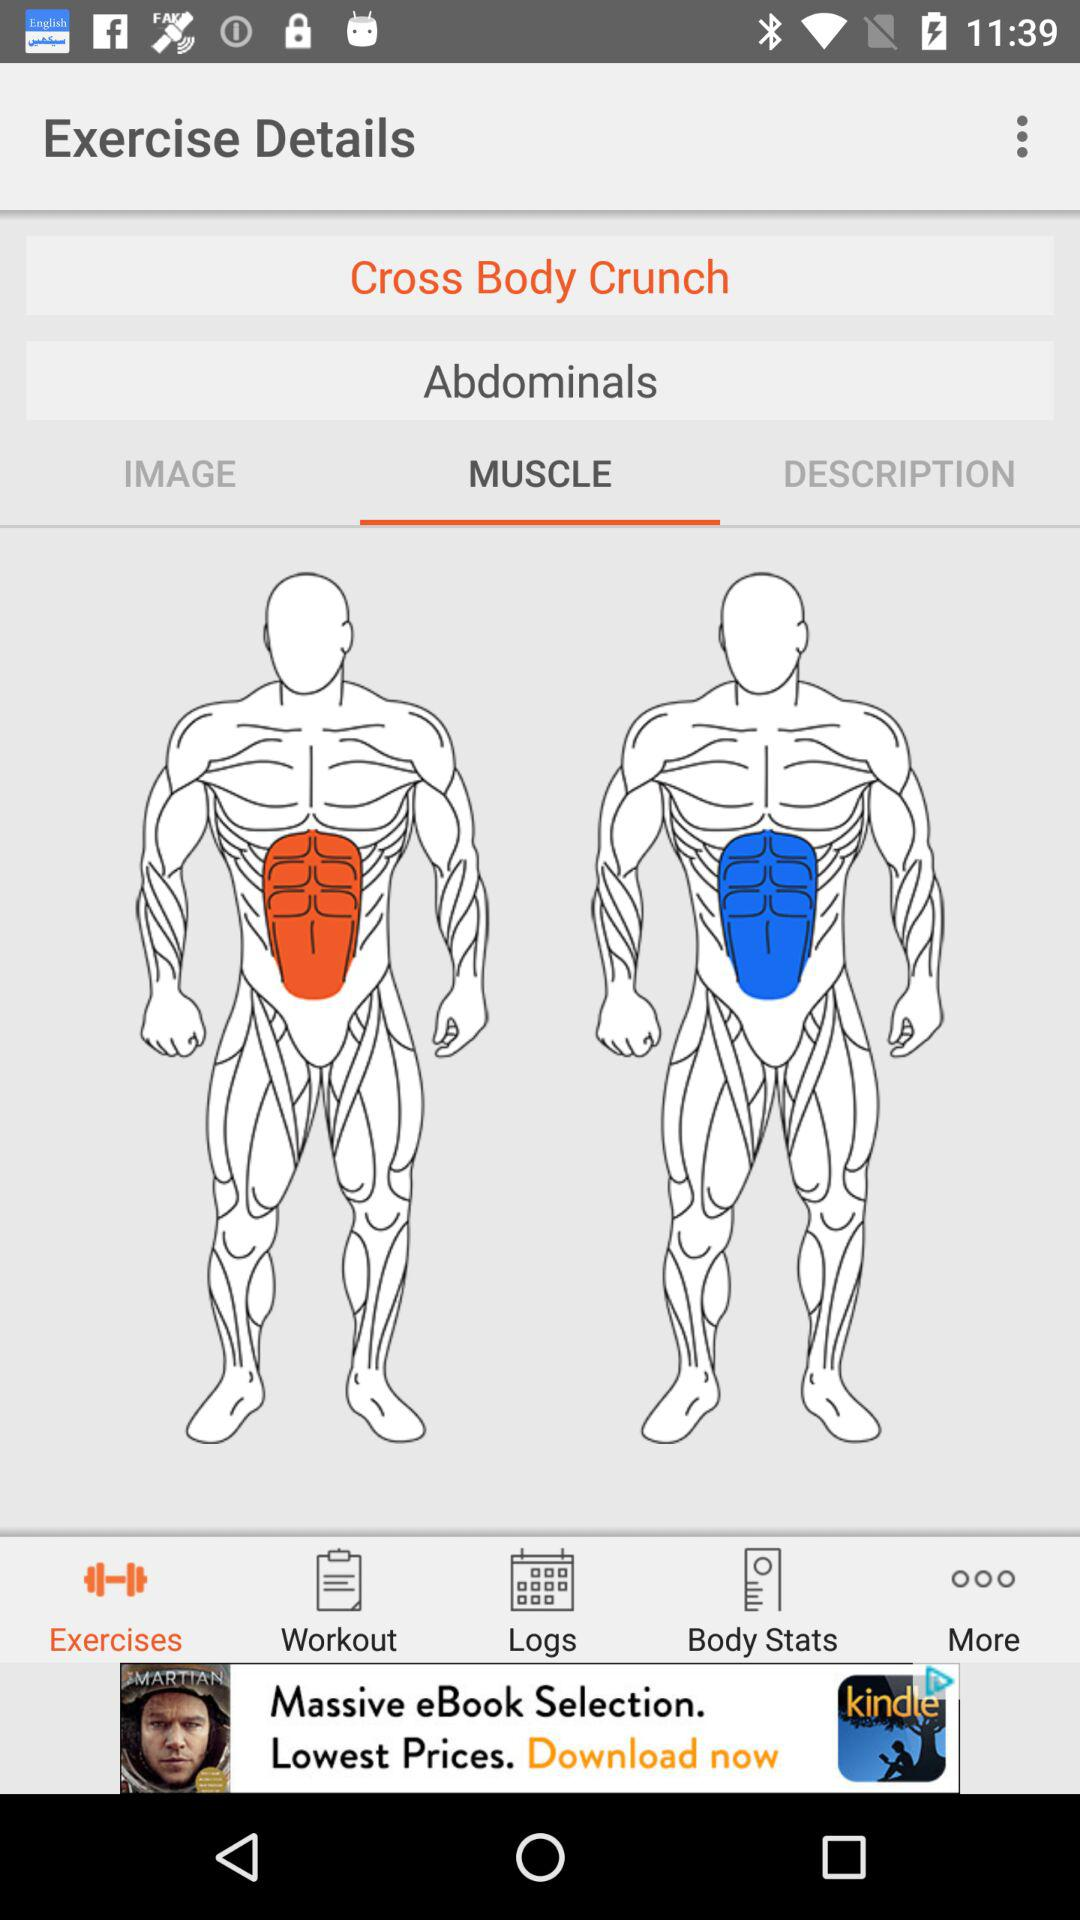What tab has been selected in the bottom row? The tab selected is "Exercises". 